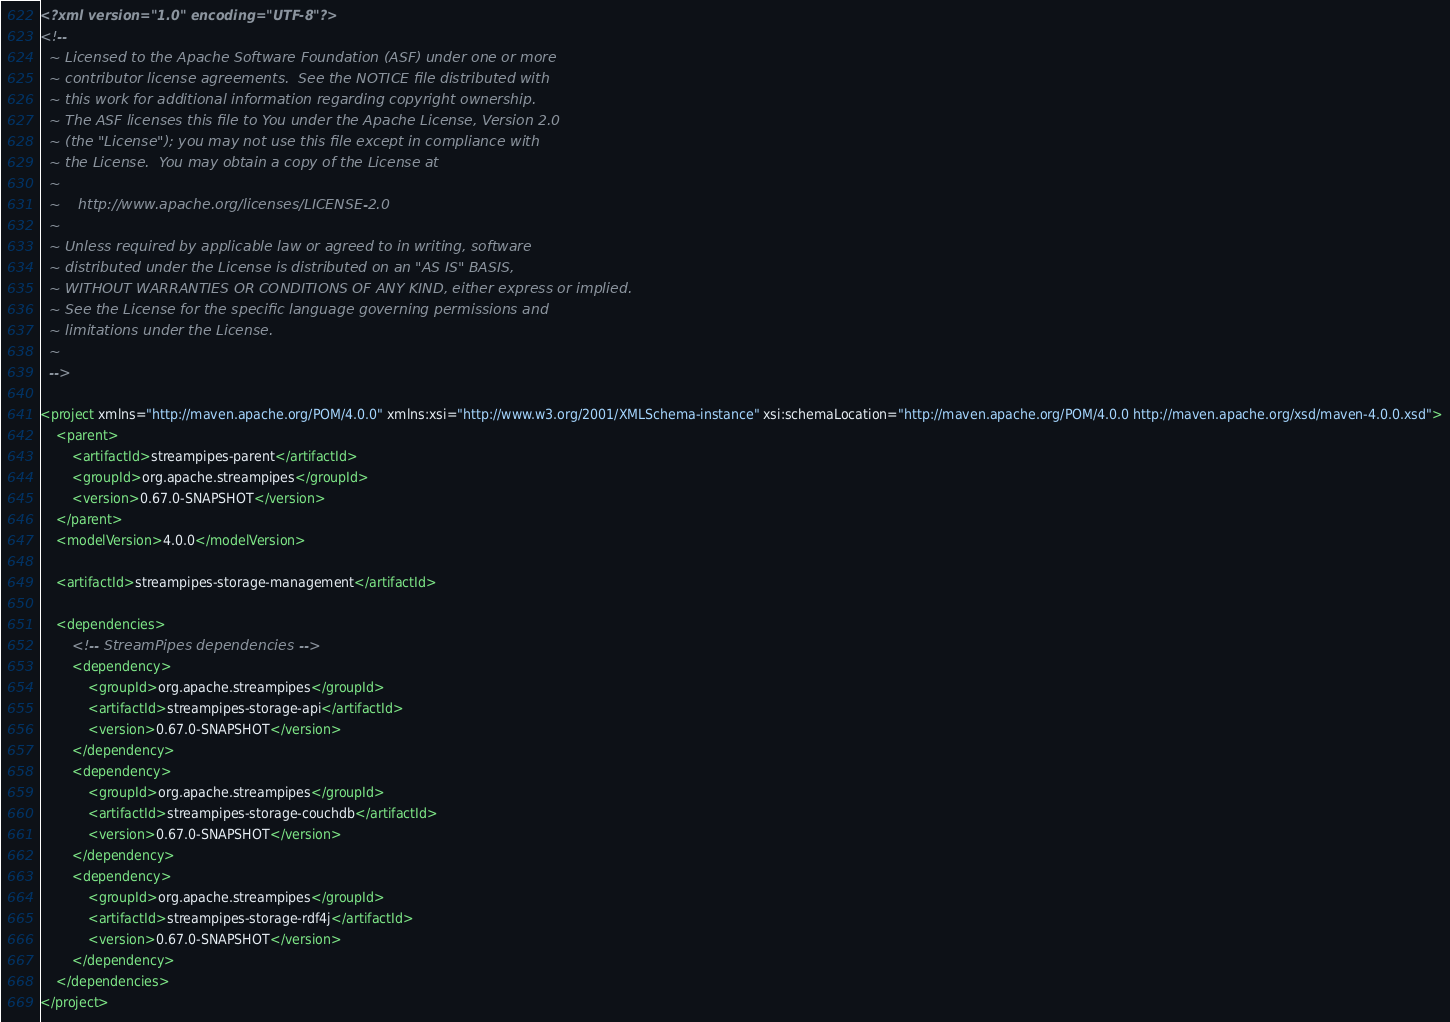Convert code to text. <code><loc_0><loc_0><loc_500><loc_500><_XML_><?xml version="1.0" encoding="UTF-8"?>
<!--
  ~ Licensed to the Apache Software Foundation (ASF) under one or more
  ~ contributor license agreements.  See the NOTICE file distributed with
  ~ this work for additional information regarding copyright ownership.
  ~ The ASF licenses this file to You under the Apache License, Version 2.0
  ~ (the "License"); you may not use this file except in compliance with
  ~ the License.  You may obtain a copy of the License at
  ~
  ~    http://www.apache.org/licenses/LICENSE-2.0
  ~
  ~ Unless required by applicable law or agreed to in writing, software
  ~ distributed under the License is distributed on an "AS IS" BASIS,
  ~ WITHOUT WARRANTIES OR CONDITIONS OF ANY KIND, either express or implied.
  ~ See the License for the specific language governing permissions and
  ~ limitations under the License.
  ~
  -->

<project xmlns="http://maven.apache.org/POM/4.0.0" xmlns:xsi="http://www.w3.org/2001/XMLSchema-instance" xsi:schemaLocation="http://maven.apache.org/POM/4.0.0 http://maven.apache.org/xsd/maven-4.0.0.xsd">
    <parent>
        <artifactId>streampipes-parent</artifactId>
        <groupId>org.apache.streampipes</groupId>
        <version>0.67.0-SNAPSHOT</version>
    </parent>
    <modelVersion>4.0.0</modelVersion>

    <artifactId>streampipes-storage-management</artifactId>

    <dependencies>
        <!-- StreamPipes dependencies -->
        <dependency>
            <groupId>org.apache.streampipes</groupId>
            <artifactId>streampipes-storage-api</artifactId>
            <version>0.67.0-SNAPSHOT</version>
        </dependency>
        <dependency>
            <groupId>org.apache.streampipes</groupId>
            <artifactId>streampipes-storage-couchdb</artifactId>
            <version>0.67.0-SNAPSHOT</version>
        </dependency>
        <dependency>
            <groupId>org.apache.streampipes</groupId>
            <artifactId>streampipes-storage-rdf4j</artifactId>
            <version>0.67.0-SNAPSHOT</version>
        </dependency>
    </dependencies>
</project></code> 